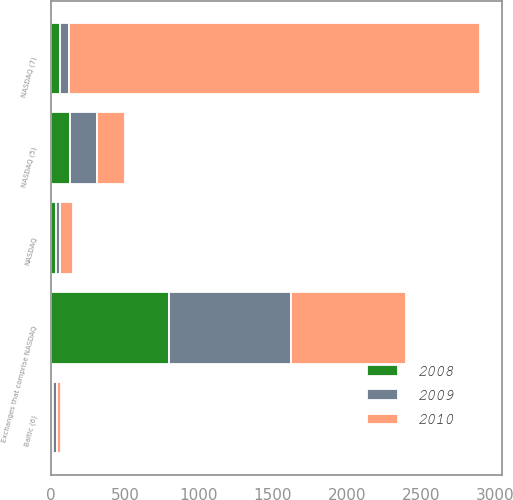<chart> <loc_0><loc_0><loc_500><loc_500><stacked_bar_chart><ecel><fcel>NASDAQ<fcel>Exchanges that comprise NASDAQ<fcel>NASDAQ (5)<fcel>Baltic (6)<fcel>NASDAQ (7)<nl><fcel>2010<fcel>89<fcel>780<fcel>195<fcel>25<fcel>2778<nl><fcel>2008<fcel>33<fcel>797<fcel>131<fcel>12<fcel>61<nl><fcel>2009<fcel>26<fcel>824<fcel>177<fcel>28<fcel>61<nl></chart> 